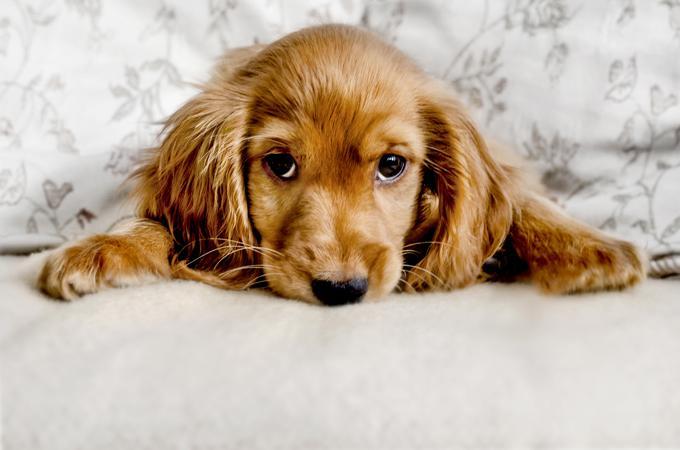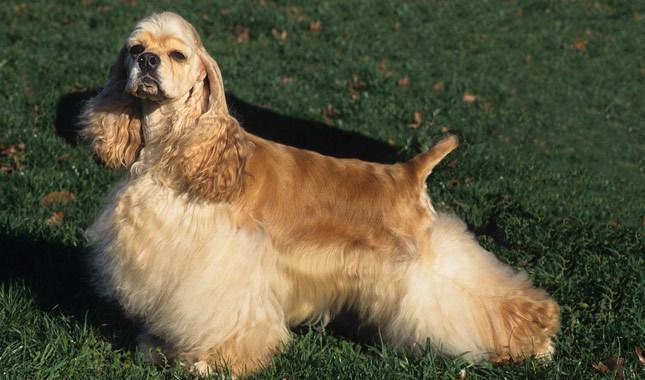The first image is the image on the left, the second image is the image on the right. Evaluate the accuracy of this statement regarding the images: "The dog in the image on the left is looking toward the camera.". Is it true? Answer yes or no. Yes. The first image is the image on the left, the second image is the image on the right. Considering the images on both sides, is "One cocker spaniel is not pictured in an outdoor setting." valid? Answer yes or no. Yes. The first image is the image on the left, the second image is the image on the right. Analyze the images presented: Is the assertion "the dog in the image on the left is lying down" valid? Answer yes or no. Yes. The first image is the image on the left, the second image is the image on the right. Assess this claim about the two images: "An image shows a cocker spaniel standing with its body in profile turned to the left.". Correct or not? Answer yes or no. Yes. The first image is the image on the left, the second image is the image on the right. Considering the images on both sides, is "There is at least one extended dog tongue in one of the images." valid? Answer yes or no. No. 